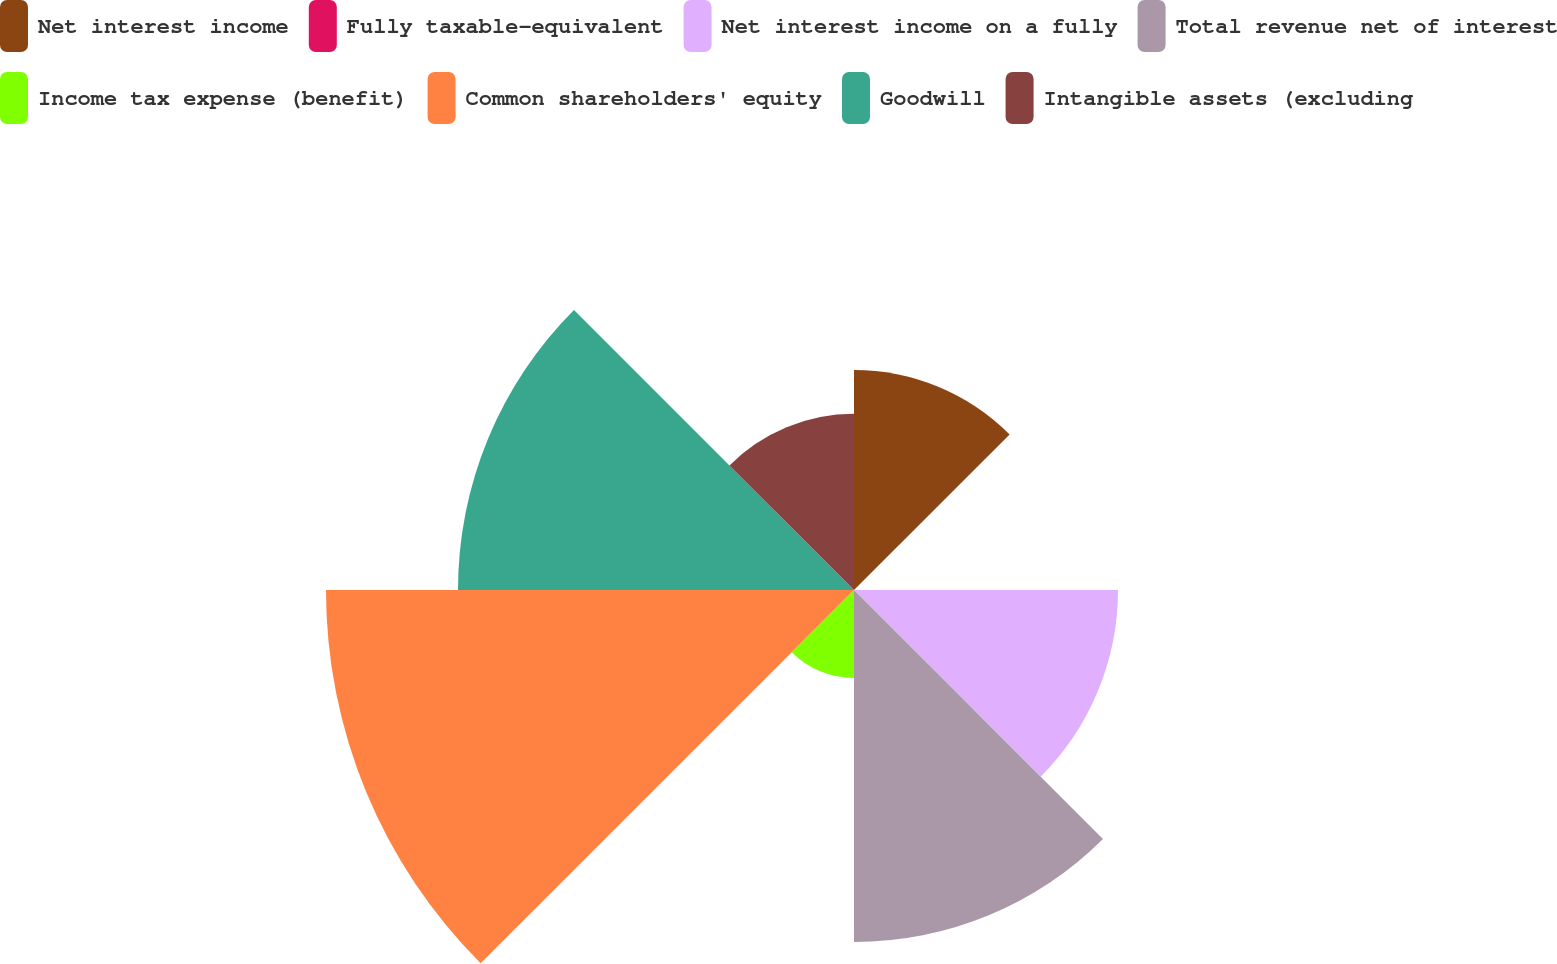Convert chart. <chart><loc_0><loc_0><loc_500><loc_500><pie_chart><fcel>Net interest income<fcel>Fully taxable-equivalent<fcel>Net interest income on a fully<fcel>Total revenue net of interest<fcel>Income tax expense (benefit)<fcel>Common shareholders' equity<fcel>Goodwill<fcel>Intangible assets (excluding<nl><fcel>10.87%<fcel>0.0%<fcel>13.04%<fcel>17.39%<fcel>4.35%<fcel>26.08%<fcel>19.56%<fcel>8.7%<nl></chart> 